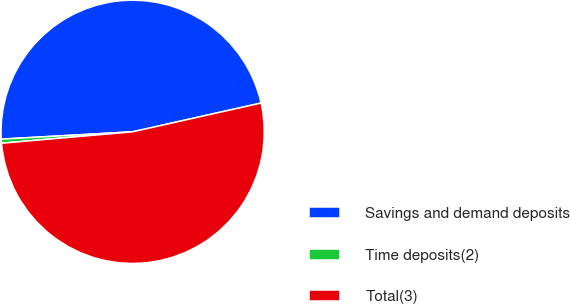Convert chart to OTSL. <chart><loc_0><loc_0><loc_500><loc_500><pie_chart><fcel>Savings and demand deposits<fcel>Time deposits(2)<fcel>Total(3)<nl><fcel>47.38%<fcel>0.5%<fcel>52.12%<nl></chart> 